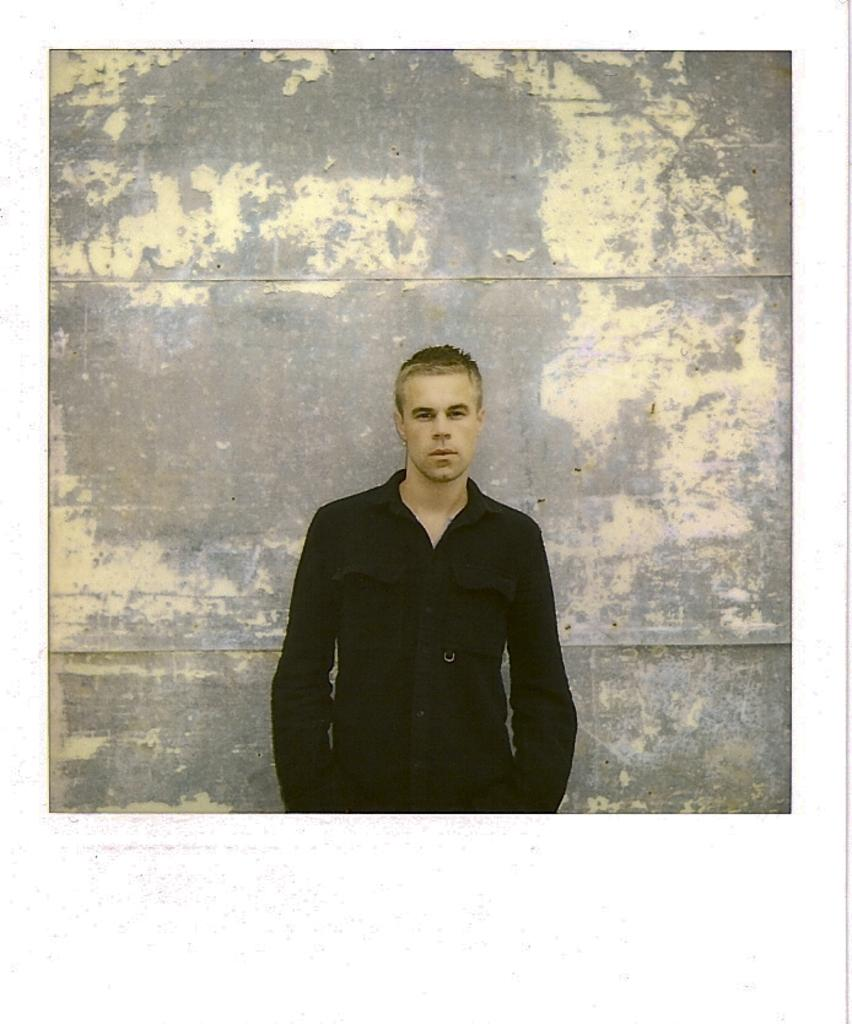Who or what is the main subject in the image? There is a person in the image. What is the person wearing? The person is wearing a black shirt. What can be seen in the background of the image? There is a wall in the background of the image. Is the person's aunt in the image? There is no mention of an aunt in the image, so it cannot be determined if the person's aunt is present. 